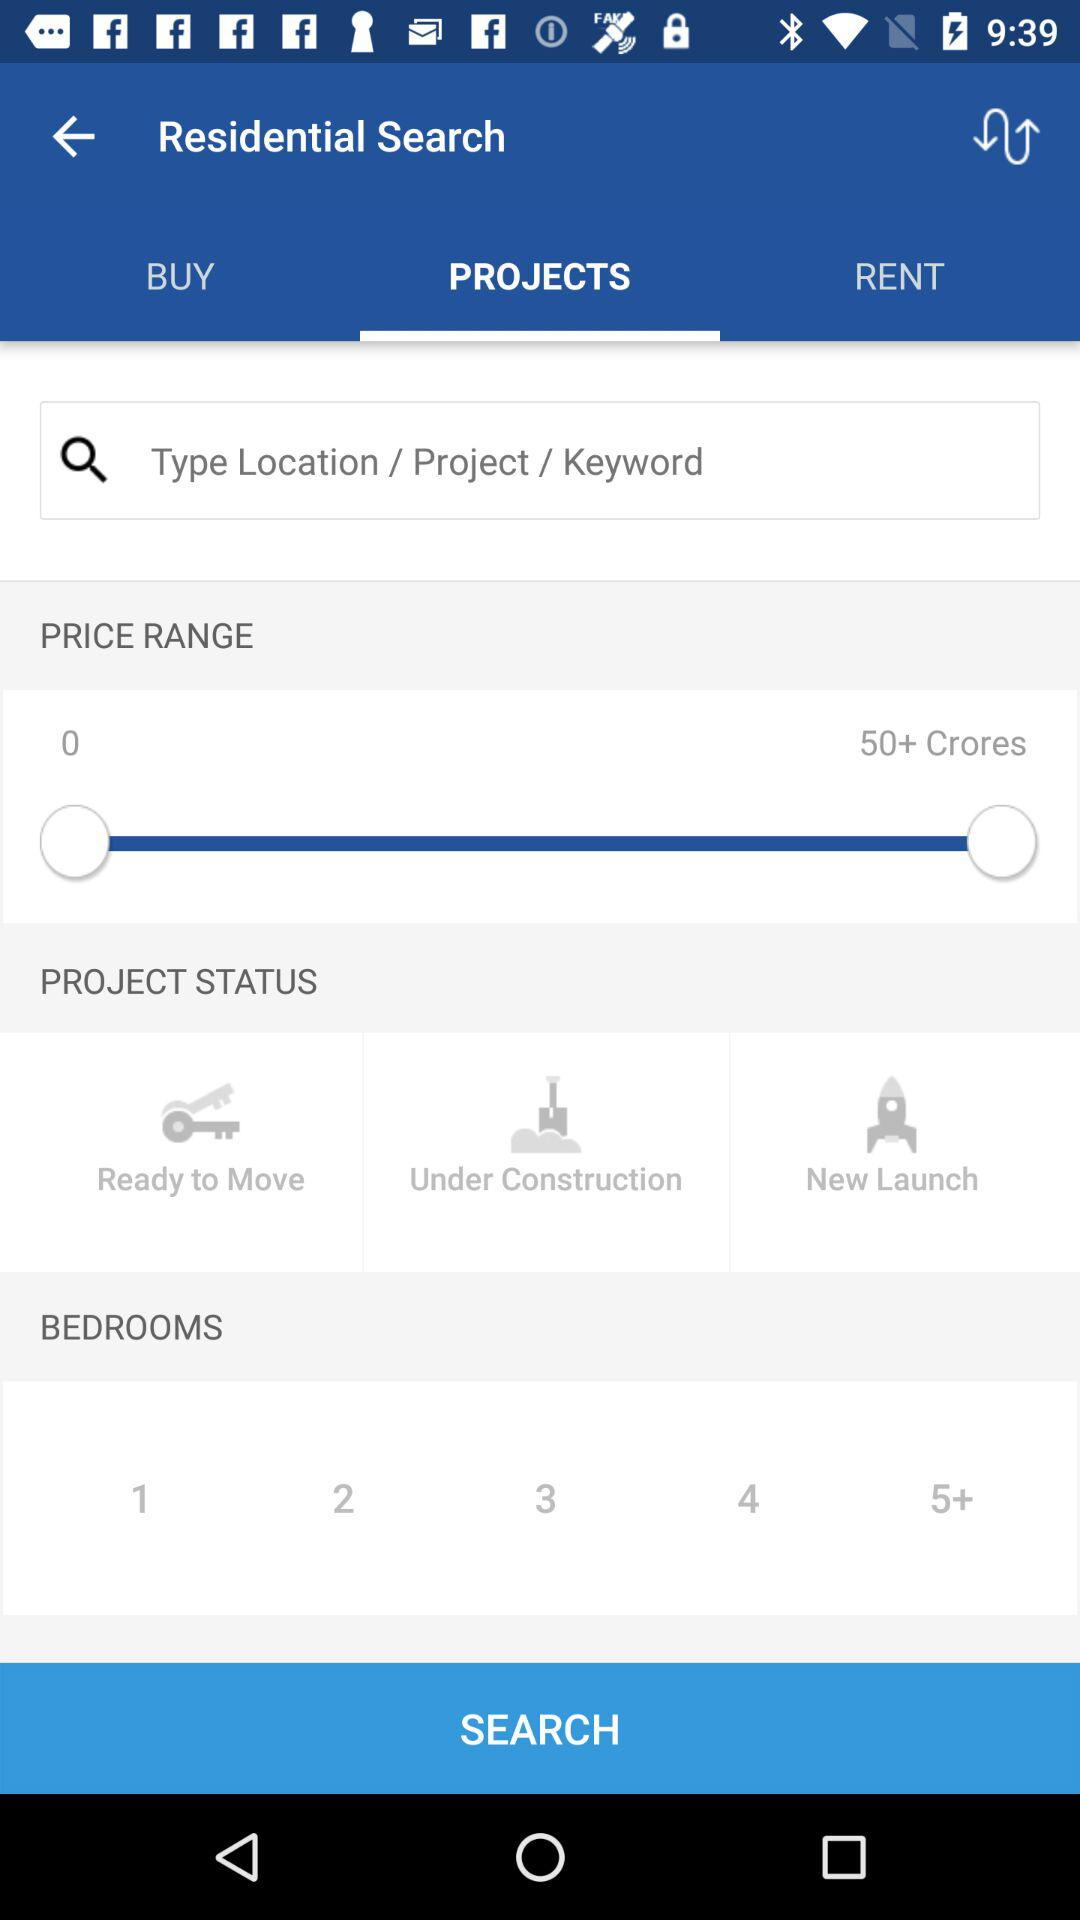Which tab am I on? You are on the "Projects" tab. 